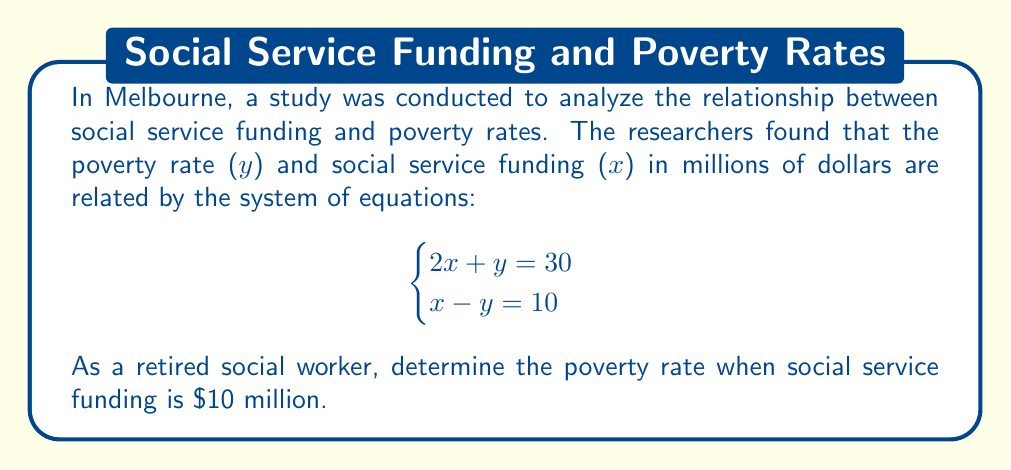Solve this math problem. Let's solve this step-by-step:

1) We have a system of two equations:
   $$\begin{cases}
   2x + y = 30 \quad (1)\\
   x - y = 10 \quad (2)
   \end{cases}$$

2) We need to solve for x and y. Let's use the substitution method.

3) From equation (2), we can express y in terms of x:
   $y = x - 10$

4) Substitute this into equation (1):
   $2x + (x - 10) = 30$

5) Simplify:
   $3x - 10 = 30$

6) Add 10 to both sides:
   $3x = 40$

7) Divide both sides by 3:
   $x = \frac{40}{3} \approx 13.33$

8) Now that we know x, we can find y using equation (2):
   $y = x - 10 = \frac{40}{3} - 10 = \frac{40-30}{3} = \frac{10}{3} \approx 3.33$

9) The question asks for the poverty rate when social service funding is $10 million. We can use either of our original equations to find this. Let's use equation (1):

   $2(10) + y = 30$
   $20 + y = 30$
   $y = 10$

Therefore, when social service funding is $10 million, the poverty rate is 10%.
Answer: 10% 